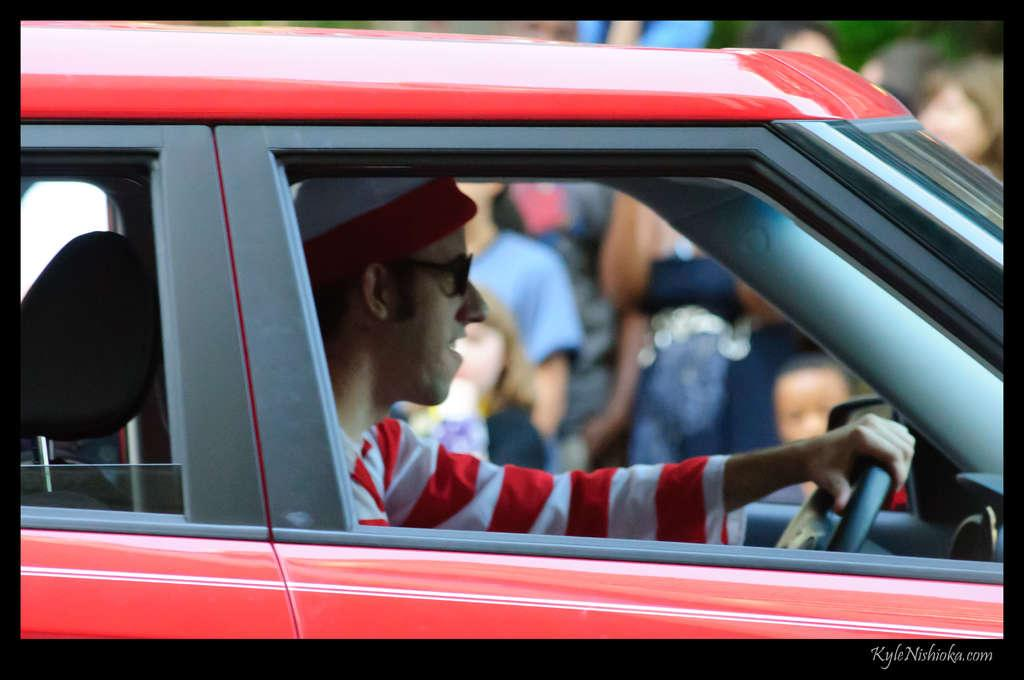What is the main subject of the image? The main subject of the image is a person driving a car. Can you describe the driver's surroundings? There are other people visible behind the driver in the image. What is the relation between the driver and the acoustics in the image? There is no mention of acoustics in the image, so it is not possible to determine any relation between the driver and acoustics. 